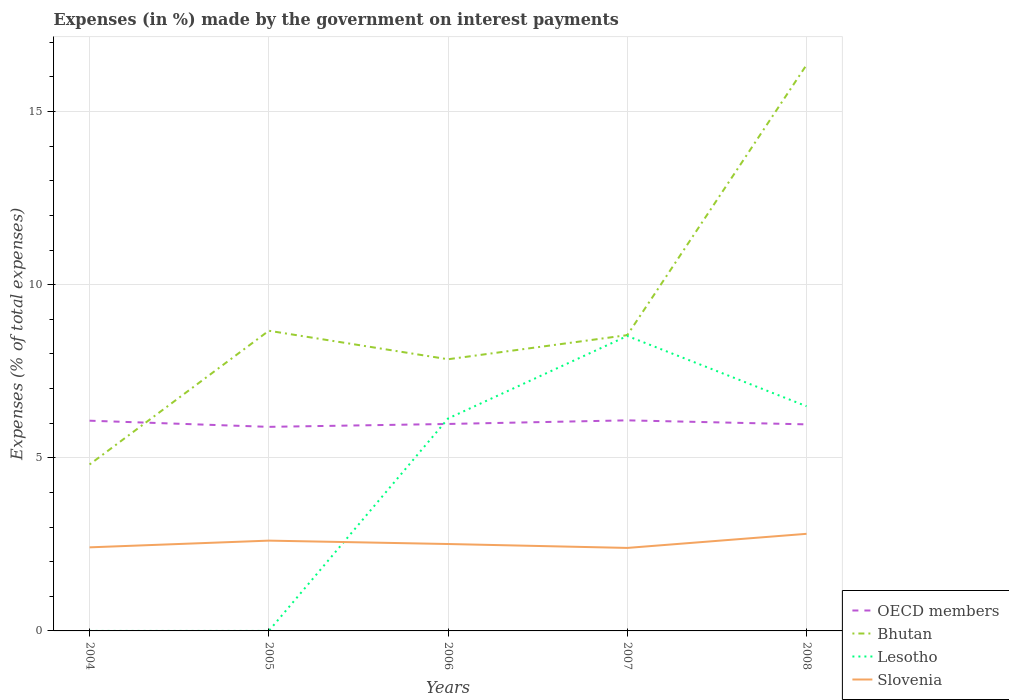Does the line corresponding to OECD members intersect with the line corresponding to Bhutan?
Keep it short and to the point. Yes. Is the number of lines equal to the number of legend labels?
Offer a terse response. Yes. Across all years, what is the maximum percentage of expenses made by the government on interest payments in Slovenia?
Offer a very short reply. 2.4. In which year was the percentage of expenses made by the government on interest payments in Lesotho maximum?
Make the answer very short. 2004. What is the total percentage of expenses made by the government on interest payments in Bhutan in the graph?
Make the answer very short. -3.04. What is the difference between the highest and the second highest percentage of expenses made by the government on interest payments in Bhutan?
Make the answer very short. 11.54. What is the difference between the highest and the lowest percentage of expenses made by the government on interest payments in OECD members?
Keep it short and to the point. 2. Is the percentage of expenses made by the government on interest payments in Slovenia strictly greater than the percentage of expenses made by the government on interest payments in OECD members over the years?
Offer a very short reply. Yes. How many lines are there?
Offer a terse response. 4. Does the graph contain any zero values?
Your answer should be compact. No. What is the title of the graph?
Provide a short and direct response. Expenses (in %) made by the government on interest payments. Does "Tonga" appear as one of the legend labels in the graph?
Your answer should be very brief. No. What is the label or title of the X-axis?
Make the answer very short. Years. What is the label or title of the Y-axis?
Your response must be concise. Expenses (% of total expenses). What is the Expenses (% of total expenses) of OECD members in 2004?
Keep it short and to the point. 6.07. What is the Expenses (% of total expenses) in Bhutan in 2004?
Your answer should be very brief. 4.81. What is the Expenses (% of total expenses) of Lesotho in 2004?
Provide a short and direct response. 2.999997087200831e-5. What is the Expenses (% of total expenses) in Slovenia in 2004?
Your response must be concise. 2.41. What is the Expenses (% of total expenses) in OECD members in 2005?
Your response must be concise. 5.89. What is the Expenses (% of total expenses) in Bhutan in 2005?
Offer a terse response. 8.67. What is the Expenses (% of total expenses) in Lesotho in 2005?
Your answer should be very brief. 0. What is the Expenses (% of total expenses) in Slovenia in 2005?
Make the answer very short. 2.61. What is the Expenses (% of total expenses) in OECD members in 2006?
Offer a terse response. 5.98. What is the Expenses (% of total expenses) in Bhutan in 2006?
Your answer should be very brief. 7.85. What is the Expenses (% of total expenses) in Lesotho in 2006?
Offer a terse response. 6.14. What is the Expenses (% of total expenses) of Slovenia in 2006?
Provide a short and direct response. 2.51. What is the Expenses (% of total expenses) in OECD members in 2007?
Your answer should be very brief. 6.08. What is the Expenses (% of total expenses) of Bhutan in 2007?
Your response must be concise. 8.54. What is the Expenses (% of total expenses) in Lesotho in 2007?
Ensure brevity in your answer.  8.52. What is the Expenses (% of total expenses) of Slovenia in 2007?
Your answer should be very brief. 2.4. What is the Expenses (% of total expenses) of OECD members in 2008?
Give a very brief answer. 5.97. What is the Expenses (% of total expenses) in Bhutan in 2008?
Ensure brevity in your answer.  16.35. What is the Expenses (% of total expenses) of Lesotho in 2008?
Offer a terse response. 6.49. What is the Expenses (% of total expenses) of Slovenia in 2008?
Make the answer very short. 2.8. Across all years, what is the maximum Expenses (% of total expenses) in OECD members?
Give a very brief answer. 6.08. Across all years, what is the maximum Expenses (% of total expenses) in Bhutan?
Provide a short and direct response. 16.35. Across all years, what is the maximum Expenses (% of total expenses) in Lesotho?
Your response must be concise. 8.52. Across all years, what is the maximum Expenses (% of total expenses) of Slovenia?
Keep it short and to the point. 2.8. Across all years, what is the minimum Expenses (% of total expenses) of OECD members?
Offer a very short reply. 5.89. Across all years, what is the minimum Expenses (% of total expenses) in Bhutan?
Make the answer very short. 4.81. Across all years, what is the minimum Expenses (% of total expenses) of Lesotho?
Give a very brief answer. 2.999997087200831e-5. Across all years, what is the minimum Expenses (% of total expenses) in Slovenia?
Offer a terse response. 2.4. What is the total Expenses (% of total expenses) of OECD members in the graph?
Your answer should be very brief. 29.99. What is the total Expenses (% of total expenses) in Bhutan in the graph?
Your answer should be very brief. 46.21. What is the total Expenses (% of total expenses) of Lesotho in the graph?
Ensure brevity in your answer.  21.14. What is the total Expenses (% of total expenses) in Slovenia in the graph?
Your answer should be very brief. 12.73. What is the difference between the Expenses (% of total expenses) of OECD members in 2004 and that in 2005?
Ensure brevity in your answer.  0.18. What is the difference between the Expenses (% of total expenses) of Bhutan in 2004 and that in 2005?
Provide a short and direct response. -3.86. What is the difference between the Expenses (% of total expenses) in Lesotho in 2004 and that in 2005?
Your answer should be very brief. -0. What is the difference between the Expenses (% of total expenses) in Slovenia in 2004 and that in 2005?
Provide a short and direct response. -0.19. What is the difference between the Expenses (% of total expenses) of OECD members in 2004 and that in 2006?
Provide a succinct answer. 0.09. What is the difference between the Expenses (% of total expenses) in Bhutan in 2004 and that in 2006?
Offer a very short reply. -3.04. What is the difference between the Expenses (% of total expenses) in Lesotho in 2004 and that in 2006?
Offer a very short reply. -6.14. What is the difference between the Expenses (% of total expenses) in Slovenia in 2004 and that in 2006?
Provide a succinct answer. -0.1. What is the difference between the Expenses (% of total expenses) of OECD members in 2004 and that in 2007?
Your answer should be compact. -0.01. What is the difference between the Expenses (% of total expenses) of Bhutan in 2004 and that in 2007?
Keep it short and to the point. -3.74. What is the difference between the Expenses (% of total expenses) in Lesotho in 2004 and that in 2007?
Your answer should be compact. -8.52. What is the difference between the Expenses (% of total expenses) of Slovenia in 2004 and that in 2007?
Your response must be concise. 0.02. What is the difference between the Expenses (% of total expenses) of OECD members in 2004 and that in 2008?
Offer a very short reply. 0.11. What is the difference between the Expenses (% of total expenses) in Bhutan in 2004 and that in 2008?
Keep it short and to the point. -11.54. What is the difference between the Expenses (% of total expenses) of Lesotho in 2004 and that in 2008?
Ensure brevity in your answer.  -6.49. What is the difference between the Expenses (% of total expenses) in Slovenia in 2004 and that in 2008?
Make the answer very short. -0.39. What is the difference between the Expenses (% of total expenses) of OECD members in 2005 and that in 2006?
Give a very brief answer. -0.08. What is the difference between the Expenses (% of total expenses) in Bhutan in 2005 and that in 2006?
Your answer should be compact. 0.82. What is the difference between the Expenses (% of total expenses) in Lesotho in 2005 and that in 2006?
Give a very brief answer. -6.14. What is the difference between the Expenses (% of total expenses) in Slovenia in 2005 and that in 2006?
Keep it short and to the point. 0.1. What is the difference between the Expenses (% of total expenses) of OECD members in 2005 and that in 2007?
Your response must be concise. -0.19. What is the difference between the Expenses (% of total expenses) in Bhutan in 2005 and that in 2007?
Your response must be concise. 0.13. What is the difference between the Expenses (% of total expenses) in Lesotho in 2005 and that in 2007?
Offer a terse response. -8.52. What is the difference between the Expenses (% of total expenses) of Slovenia in 2005 and that in 2007?
Your answer should be very brief. 0.21. What is the difference between the Expenses (% of total expenses) of OECD members in 2005 and that in 2008?
Keep it short and to the point. -0.07. What is the difference between the Expenses (% of total expenses) of Bhutan in 2005 and that in 2008?
Your response must be concise. -7.68. What is the difference between the Expenses (% of total expenses) of Lesotho in 2005 and that in 2008?
Make the answer very short. -6.49. What is the difference between the Expenses (% of total expenses) in Slovenia in 2005 and that in 2008?
Your response must be concise. -0.2. What is the difference between the Expenses (% of total expenses) in OECD members in 2006 and that in 2007?
Keep it short and to the point. -0.1. What is the difference between the Expenses (% of total expenses) in Bhutan in 2006 and that in 2007?
Your answer should be compact. -0.7. What is the difference between the Expenses (% of total expenses) in Lesotho in 2006 and that in 2007?
Provide a succinct answer. -2.38. What is the difference between the Expenses (% of total expenses) in Slovenia in 2006 and that in 2007?
Offer a very short reply. 0.11. What is the difference between the Expenses (% of total expenses) of OECD members in 2006 and that in 2008?
Your answer should be very brief. 0.01. What is the difference between the Expenses (% of total expenses) of Bhutan in 2006 and that in 2008?
Your answer should be very brief. -8.5. What is the difference between the Expenses (% of total expenses) of Lesotho in 2006 and that in 2008?
Give a very brief answer. -0.35. What is the difference between the Expenses (% of total expenses) of Slovenia in 2006 and that in 2008?
Provide a short and direct response. -0.29. What is the difference between the Expenses (% of total expenses) in OECD members in 2007 and that in 2008?
Offer a terse response. 0.12. What is the difference between the Expenses (% of total expenses) in Bhutan in 2007 and that in 2008?
Your answer should be very brief. -7.81. What is the difference between the Expenses (% of total expenses) of Lesotho in 2007 and that in 2008?
Ensure brevity in your answer.  2.03. What is the difference between the Expenses (% of total expenses) of Slovenia in 2007 and that in 2008?
Give a very brief answer. -0.41. What is the difference between the Expenses (% of total expenses) in OECD members in 2004 and the Expenses (% of total expenses) in Bhutan in 2005?
Ensure brevity in your answer.  -2.6. What is the difference between the Expenses (% of total expenses) in OECD members in 2004 and the Expenses (% of total expenses) in Lesotho in 2005?
Offer a very short reply. 6.07. What is the difference between the Expenses (% of total expenses) in OECD members in 2004 and the Expenses (% of total expenses) in Slovenia in 2005?
Your response must be concise. 3.46. What is the difference between the Expenses (% of total expenses) in Bhutan in 2004 and the Expenses (% of total expenses) in Lesotho in 2005?
Offer a terse response. 4.81. What is the difference between the Expenses (% of total expenses) of Bhutan in 2004 and the Expenses (% of total expenses) of Slovenia in 2005?
Provide a succinct answer. 2.2. What is the difference between the Expenses (% of total expenses) in Lesotho in 2004 and the Expenses (% of total expenses) in Slovenia in 2005?
Your answer should be very brief. -2.61. What is the difference between the Expenses (% of total expenses) in OECD members in 2004 and the Expenses (% of total expenses) in Bhutan in 2006?
Give a very brief answer. -1.77. What is the difference between the Expenses (% of total expenses) in OECD members in 2004 and the Expenses (% of total expenses) in Lesotho in 2006?
Give a very brief answer. -0.06. What is the difference between the Expenses (% of total expenses) in OECD members in 2004 and the Expenses (% of total expenses) in Slovenia in 2006?
Make the answer very short. 3.56. What is the difference between the Expenses (% of total expenses) in Bhutan in 2004 and the Expenses (% of total expenses) in Lesotho in 2006?
Offer a terse response. -1.33. What is the difference between the Expenses (% of total expenses) in Bhutan in 2004 and the Expenses (% of total expenses) in Slovenia in 2006?
Your answer should be very brief. 2.3. What is the difference between the Expenses (% of total expenses) of Lesotho in 2004 and the Expenses (% of total expenses) of Slovenia in 2006?
Ensure brevity in your answer.  -2.51. What is the difference between the Expenses (% of total expenses) of OECD members in 2004 and the Expenses (% of total expenses) of Bhutan in 2007?
Provide a succinct answer. -2.47. What is the difference between the Expenses (% of total expenses) in OECD members in 2004 and the Expenses (% of total expenses) in Lesotho in 2007?
Provide a succinct answer. -2.45. What is the difference between the Expenses (% of total expenses) in OECD members in 2004 and the Expenses (% of total expenses) in Slovenia in 2007?
Provide a succinct answer. 3.67. What is the difference between the Expenses (% of total expenses) in Bhutan in 2004 and the Expenses (% of total expenses) in Lesotho in 2007?
Give a very brief answer. -3.71. What is the difference between the Expenses (% of total expenses) in Bhutan in 2004 and the Expenses (% of total expenses) in Slovenia in 2007?
Offer a terse response. 2.41. What is the difference between the Expenses (% of total expenses) in Lesotho in 2004 and the Expenses (% of total expenses) in Slovenia in 2007?
Give a very brief answer. -2.4. What is the difference between the Expenses (% of total expenses) of OECD members in 2004 and the Expenses (% of total expenses) of Bhutan in 2008?
Your response must be concise. -10.28. What is the difference between the Expenses (% of total expenses) in OECD members in 2004 and the Expenses (% of total expenses) in Lesotho in 2008?
Make the answer very short. -0.42. What is the difference between the Expenses (% of total expenses) in OECD members in 2004 and the Expenses (% of total expenses) in Slovenia in 2008?
Your answer should be very brief. 3.27. What is the difference between the Expenses (% of total expenses) of Bhutan in 2004 and the Expenses (% of total expenses) of Lesotho in 2008?
Keep it short and to the point. -1.68. What is the difference between the Expenses (% of total expenses) of Bhutan in 2004 and the Expenses (% of total expenses) of Slovenia in 2008?
Your response must be concise. 2. What is the difference between the Expenses (% of total expenses) in Lesotho in 2004 and the Expenses (% of total expenses) in Slovenia in 2008?
Ensure brevity in your answer.  -2.8. What is the difference between the Expenses (% of total expenses) in OECD members in 2005 and the Expenses (% of total expenses) in Bhutan in 2006?
Provide a succinct answer. -1.95. What is the difference between the Expenses (% of total expenses) of OECD members in 2005 and the Expenses (% of total expenses) of Lesotho in 2006?
Provide a succinct answer. -0.24. What is the difference between the Expenses (% of total expenses) of OECD members in 2005 and the Expenses (% of total expenses) of Slovenia in 2006?
Provide a succinct answer. 3.38. What is the difference between the Expenses (% of total expenses) of Bhutan in 2005 and the Expenses (% of total expenses) of Lesotho in 2006?
Keep it short and to the point. 2.53. What is the difference between the Expenses (% of total expenses) in Bhutan in 2005 and the Expenses (% of total expenses) in Slovenia in 2006?
Your answer should be very brief. 6.16. What is the difference between the Expenses (% of total expenses) of Lesotho in 2005 and the Expenses (% of total expenses) of Slovenia in 2006?
Ensure brevity in your answer.  -2.51. What is the difference between the Expenses (% of total expenses) of OECD members in 2005 and the Expenses (% of total expenses) of Bhutan in 2007?
Make the answer very short. -2.65. What is the difference between the Expenses (% of total expenses) of OECD members in 2005 and the Expenses (% of total expenses) of Lesotho in 2007?
Make the answer very short. -2.63. What is the difference between the Expenses (% of total expenses) in OECD members in 2005 and the Expenses (% of total expenses) in Slovenia in 2007?
Your response must be concise. 3.5. What is the difference between the Expenses (% of total expenses) in Bhutan in 2005 and the Expenses (% of total expenses) in Lesotho in 2007?
Your response must be concise. 0.15. What is the difference between the Expenses (% of total expenses) in Bhutan in 2005 and the Expenses (% of total expenses) in Slovenia in 2007?
Ensure brevity in your answer.  6.27. What is the difference between the Expenses (% of total expenses) of Lesotho in 2005 and the Expenses (% of total expenses) of Slovenia in 2007?
Your answer should be compact. -2.4. What is the difference between the Expenses (% of total expenses) in OECD members in 2005 and the Expenses (% of total expenses) in Bhutan in 2008?
Make the answer very short. -10.45. What is the difference between the Expenses (% of total expenses) in OECD members in 2005 and the Expenses (% of total expenses) in Lesotho in 2008?
Ensure brevity in your answer.  -0.6. What is the difference between the Expenses (% of total expenses) of OECD members in 2005 and the Expenses (% of total expenses) of Slovenia in 2008?
Keep it short and to the point. 3.09. What is the difference between the Expenses (% of total expenses) in Bhutan in 2005 and the Expenses (% of total expenses) in Lesotho in 2008?
Your answer should be very brief. 2.18. What is the difference between the Expenses (% of total expenses) in Bhutan in 2005 and the Expenses (% of total expenses) in Slovenia in 2008?
Ensure brevity in your answer.  5.87. What is the difference between the Expenses (% of total expenses) in Lesotho in 2005 and the Expenses (% of total expenses) in Slovenia in 2008?
Your response must be concise. -2.8. What is the difference between the Expenses (% of total expenses) in OECD members in 2006 and the Expenses (% of total expenses) in Bhutan in 2007?
Offer a very short reply. -2.57. What is the difference between the Expenses (% of total expenses) in OECD members in 2006 and the Expenses (% of total expenses) in Lesotho in 2007?
Make the answer very short. -2.54. What is the difference between the Expenses (% of total expenses) in OECD members in 2006 and the Expenses (% of total expenses) in Slovenia in 2007?
Offer a very short reply. 3.58. What is the difference between the Expenses (% of total expenses) of Bhutan in 2006 and the Expenses (% of total expenses) of Lesotho in 2007?
Your answer should be compact. -0.67. What is the difference between the Expenses (% of total expenses) in Bhutan in 2006 and the Expenses (% of total expenses) in Slovenia in 2007?
Give a very brief answer. 5.45. What is the difference between the Expenses (% of total expenses) in Lesotho in 2006 and the Expenses (% of total expenses) in Slovenia in 2007?
Offer a terse response. 3.74. What is the difference between the Expenses (% of total expenses) of OECD members in 2006 and the Expenses (% of total expenses) of Bhutan in 2008?
Offer a terse response. -10.37. What is the difference between the Expenses (% of total expenses) of OECD members in 2006 and the Expenses (% of total expenses) of Lesotho in 2008?
Your response must be concise. -0.51. What is the difference between the Expenses (% of total expenses) of OECD members in 2006 and the Expenses (% of total expenses) of Slovenia in 2008?
Offer a terse response. 3.17. What is the difference between the Expenses (% of total expenses) in Bhutan in 2006 and the Expenses (% of total expenses) in Lesotho in 2008?
Your answer should be very brief. 1.36. What is the difference between the Expenses (% of total expenses) of Bhutan in 2006 and the Expenses (% of total expenses) of Slovenia in 2008?
Provide a short and direct response. 5.04. What is the difference between the Expenses (% of total expenses) in Lesotho in 2006 and the Expenses (% of total expenses) in Slovenia in 2008?
Ensure brevity in your answer.  3.33. What is the difference between the Expenses (% of total expenses) in OECD members in 2007 and the Expenses (% of total expenses) in Bhutan in 2008?
Ensure brevity in your answer.  -10.27. What is the difference between the Expenses (% of total expenses) in OECD members in 2007 and the Expenses (% of total expenses) in Lesotho in 2008?
Your answer should be compact. -0.41. What is the difference between the Expenses (% of total expenses) of OECD members in 2007 and the Expenses (% of total expenses) of Slovenia in 2008?
Give a very brief answer. 3.28. What is the difference between the Expenses (% of total expenses) of Bhutan in 2007 and the Expenses (% of total expenses) of Lesotho in 2008?
Make the answer very short. 2.05. What is the difference between the Expenses (% of total expenses) in Bhutan in 2007 and the Expenses (% of total expenses) in Slovenia in 2008?
Offer a very short reply. 5.74. What is the difference between the Expenses (% of total expenses) of Lesotho in 2007 and the Expenses (% of total expenses) of Slovenia in 2008?
Your answer should be compact. 5.72. What is the average Expenses (% of total expenses) in OECD members per year?
Provide a succinct answer. 6. What is the average Expenses (% of total expenses) of Bhutan per year?
Provide a short and direct response. 9.24. What is the average Expenses (% of total expenses) in Lesotho per year?
Make the answer very short. 4.23. What is the average Expenses (% of total expenses) of Slovenia per year?
Make the answer very short. 2.55. In the year 2004, what is the difference between the Expenses (% of total expenses) of OECD members and Expenses (% of total expenses) of Bhutan?
Your answer should be very brief. 1.26. In the year 2004, what is the difference between the Expenses (% of total expenses) of OECD members and Expenses (% of total expenses) of Lesotho?
Your response must be concise. 6.07. In the year 2004, what is the difference between the Expenses (% of total expenses) in OECD members and Expenses (% of total expenses) in Slovenia?
Your response must be concise. 3.66. In the year 2004, what is the difference between the Expenses (% of total expenses) in Bhutan and Expenses (% of total expenses) in Lesotho?
Your response must be concise. 4.81. In the year 2004, what is the difference between the Expenses (% of total expenses) of Bhutan and Expenses (% of total expenses) of Slovenia?
Your response must be concise. 2.39. In the year 2004, what is the difference between the Expenses (% of total expenses) of Lesotho and Expenses (% of total expenses) of Slovenia?
Ensure brevity in your answer.  -2.41. In the year 2005, what is the difference between the Expenses (% of total expenses) of OECD members and Expenses (% of total expenses) of Bhutan?
Provide a succinct answer. -2.78. In the year 2005, what is the difference between the Expenses (% of total expenses) of OECD members and Expenses (% of total expenses) of Lesotho?
Make the answer very short. 5.89. In the year 2005, what is the difference between the Expenses (% of total expenses) in OECD members and Expenses (% of total expenses) in Slovenia?
Keep it short and to the point. 3.29. In the year 2005, what is the difference between the Expenses (% of total expenses) of Bhutan and Expenses (% of total expenses) of Lesotho?
Offer a very short reply. 8.67. In the year 2005, what is the difference between the Expenses (% of total expenses) in Bhutan and Expenses (% of total expenses) in Slovenia?
Offer a terse response. 6.06. In the year 2005, what is the difference between the Expenses (% of total expenses) of Lesotho and Expenses (% of total expenses) of Slovenia?
Your answer should be very brief. -2.61. In the year 2006, what is the difference between the Expenses (% of total expenses) of OECD members and Expenses (% of total expenses) of Bhutan?
Ensure brevity in your answer.  -1.87. In the year 2006, what is the difference between the Expenses (% of total expenses) of OECD members and Expenses (% of total expenses) of Lesotho?
Make the answer very short. -0.16. In the year 2006, what is the difference between the Expenses (% of total expenses) of OECD members and Expenses (% of total expenses) of Slovenia?
Your response must be concise. 3.47. In the year 2006, what is the difference between the Expenses (% of total expenses) of Bhutan and Expenses (% of total expenses) of Lesotho?
Offer a very short reply. 1.71. In the year 2006, what is the difference between the Expenses (% of total expenses) in Bhutan and Expenses (% of total expenses) in Slovenia?
Offer a very short reply. 5.34. In the year 2006, what is the difference between the Expenses (% of total expenses) in Lesotho and Expenses (% of total expenses) in Slovenia?
Give a very brief answer. 3.63. In the year 2007, what is the difference between the Expenses (% of total expenses) of OECD members and Expenses (% of total expenses) of Bhutan?
Provide a short and direct response. -2.46. In the year 2007, what is the difference between the Expenses (% of total expenses) in OECD members and Expenses (% of total expenses) in Lesotho?
Give a very brief answer. -2.44. In the year 2007, what is the difference between the Expenses (% of total expenses) of OECD members and Expenses (% of total expenses) of Slovenia?
Keep it short and to the point. 3.68. In the year 2007, what is the difference between the Expenses (% of total expenses) of Bhutan and Expenses (% of total expenses) of Lesotho?
Your answer should be very brief. 0.02. In the year 2007, what is the difference between the Expenses (% of total expenses) in Bhutan and Expenses (% of total expenses) in Slovenia?
Provide a succinct answer. 6.15. In the year 2007, what is the difference between the Expenses (% of total expenses) in Lesotho and Expenses (% of total expenses) in Slovenia?
Make the answer very short. 6.12. In the year 2008, what is the difference between the Expenses (% of total expenses) of OECD members and Expenses (% of total expenses) of Bhutan?
Your answer should be very brief. -10.38. In the year 2008, what is the difference between the Expenses (% of total expenses) of OECD members and Expenses (% of total expenses) of Lesotho?
Offer a very short reply. -0.52. In the year 2008, what is the difference between the Expenses (% of total expenses) of OECD members and Expenses (% of total expenses) of Slovenia?
Offer a very short reply. 3.16. In the year 2008, what is the difference between the Expenses (% of total expenses) in Bhutan and Expenses (% of total expenses) in Lesotho?
Ensure brevity in your answer.  9.86. In the year 2008, what is the difference between the Expenses (% of total expenses) of Bhutan and Expenses (% of total expenses) of Slovenia?
Provide a short and direct response. 13.54. In the year 2008, what is the difference between the Expenses (% of total expenses) in Lesotho and Expenses (% of total expenses) in Slovenia?
Your answer should be very brief. 3.68. What is the ratio of the Expenses (% of total expenses) of OECD members in 2004 to that in 2005?
Provide a short and direct response. 1.03. What is the ratio of the Expenses (% of total expenses) of Bhutan in 2004 to that in 2005?
Make the answer very short. 0.55. What is the ratio of the Expenses (% of total expenses) of Lesotho in 2004 to that in 2005?
Keep it short and to the point. 0.3. What is the ratio of the Expenses (% of total expenses) in Slovenia in 2004 to that in 2005?
Provide a succinct answer. 0.93. What is the ratio of the Expenses (% of total expenses) in OECD members in 2004 to that in 2006?
Offer a terse response. 1.02. What is the ratio of the Expenses (% of total expenses) in Bhutan in 2004 to that in 2006?
Your answer should be compact. 0.61. What is the ratio of the Expenses (% of total expenses) in Slovenia in 2004 to that in 2006?
Provide a succinct answer. 0.96. What is the ratio of the Expenses (% of total expenses) of Bhutan in 2004 to that in 2007?
Your answer should be very brief. 0.56. What is the ratio of the Expenses (% of total expenses) in Lesotho in 2004 to that in 2007?
Provide a short and direct response. 0. What is the ratio of the Expenses (% of total expenses) in Slovenia in 2004 to that in 2007?
Provide a succinct answer. 1.01. What is the ratio of the Expenses (% of total expenses) of OECD members in 2004 to that in 2008?
Give a very brief answer. 1.02. What is the ratio of the Expenses (% of total expenses) in Bhutan in 2004 to that in 2008?
Ensure brevity in your answer.  0.29. What is the ratio of the Expenses (% of total expenses) in Lesotho in 2004 to that in 2008?
Give a very brief answer. 0. What is the ratio of the Expenses (% of total expenses) of Slovenia in 2004 to that in 2008?
Offer a terse response. 0.86. What is the ratio of the Expenses (% of total expenses) in Bhutan in 2005 to that in 2006?
Offer a terse response. 1.1. What is the ratio of the Expenses (% of total expenses) of Slovenia in 2005 to that in 2006?
Your response must be concise. 1.04. What is the ratio of the Expenses (% of total expenses) of OECD members in 2005 to that in 2007?
Keep it short and to the point. 0.97. What is the ratio of the Expenses (% of total expenses) of Bhutan in 2005 to that in 2007?
Your response must be concise. 1.01. What is the ratio of the Expenses (% of total expenses) in Lesotho in 2005 to that in 2007?
Your response must be concise. 0. What is the ratio of the Expenses (% of total expenses) of Slovenia in 2005 to that in 2007?
Your answer should be compact. 1.09. What is the ratio of the Expenses (% of total expenses) in OECD members in 2005 to that in 2008?
Provide a succinct answer. 0.99. What is the ratio of the Expenses (% of total expenses) in Bhutan in 2005 to that in 2008?
Provide a short and direct response. 0.53. What is the ratio of the Expenses (% of total expenses) of Slovenia in 2005 to that in 2008?
Make the answer very short. 0.93. What is the ratio of the Expenses (% of total expenses) in OECD members in 2006 to that in 2007?
Your response must be concise. 0.98. What is the ratio of the Expenses (% of total expenses) of Bhutan in 2006 to that in 2007?
Make the answer very short. 0.92. What is the ratio of the Expenses (% of total expenses) in Lesotho in 2006 to that in 2007?
Ensure brevity in your answer.  0.72. What is the ratio of the Expenses (% of total expenses) of Slovenia in 2006 to that in 2007?
Make the answer very short. 1.05. What is the ratio of the Expenses (% of total expenses) in Bhutan in 2006 to that in 2008?
Keep it short and to the point. 0.48. What is the ratio of the Expenses (% of total expenses) of Lesotho in 2006 to that in 2008?
Keep it short and to the point. 0.95. What is the ratio of the Expenses (% of total expenses) in Slovenia in 2006 to that in 2008?
Your answer should be very brief. 0.9. What is the ratio of the Expenses (% of total expenses) of OECD members in 2007 to that in 2008?
Offer a very short reply. 1.02. What is the ratio of the Expenses (% of total expenses) of Bhutan in 2007 to that in 2008?
Offer a terse response. 0.52. What is the ratio of the Expenses (% of total expenses) in Lesotho in 2007 to that in 2008?
Offer a very short reply. 1.31. What is the ratio of the Expenses (% of total expenses) of Slovenia in 2007 to that in 2008?
Offer a very short reply. 0.85. What is the difference between the highest and the second highest Expenses (% of total expenses) of OECD members?
Your response must be concise. 0.01. What is the difference between the highest and the second highest Expenses (% of total expenses) in Bhutan?
Your response must be concise. 7.68. What is the difference between the highest and the second highest Expenses (% of total expenses) in Lesotho?
Keep it short and to the point. 2.03. What is the difference between the highest and the second highest Expenses (% of total expenses) in Slovenia?
Offer a terse response. 0.2. What is the difference between the highest and the lowest Expenses (% of total expenses) of OECD members?
Make the answer very short. 0.19. What is the difference between the highest and the lowest Expenses (% of total expenses) of Bhutan?
Make the answer very short. 11.54. What is the difference between the highest and the lowest Expenses (% of total expenses) in Lesotho?
Offer a very short reply. 8.52. What is the difference between the highest and the lowest Expenses (% of total expenses) of Slovenia?
Your answer should be very brief. 0.41. 